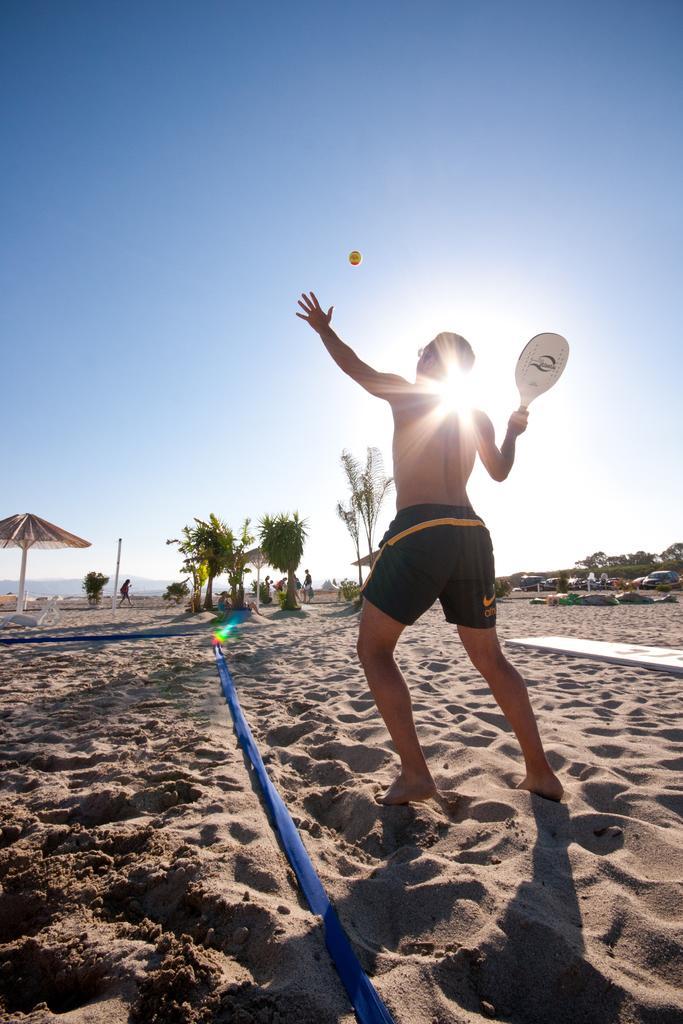Can you describe this image briefly? There is a person holding a racket with his hand and in a position to hit a ball. This is sand. Here we can see an umbrella, pole, vehicles, trees, and few persons. In the background there is sky. 